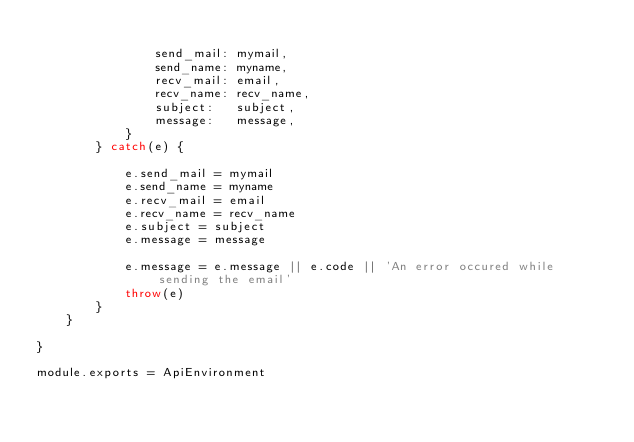<code> <loc_0><loc_0><loc_500><loc_500><_JavaScript_>
                send_mail: mymail,
                send_name: myname,
                recv_mail: email,
                recv_name: recv_name,
                subject:   subject,
                message:   message,
            }
        } catch(e) {

            e.send_mail = mymail
            e.send_name = myname
            e.recv_mail = email
            e.recv_name = recv_name
            e.subject = subject
            e.message = message

            e.message = e.message || e.code || 'An error occured while sending the email'
            throw(e)
        }
    }

}

module.exports = ApiEnvironment</code> 